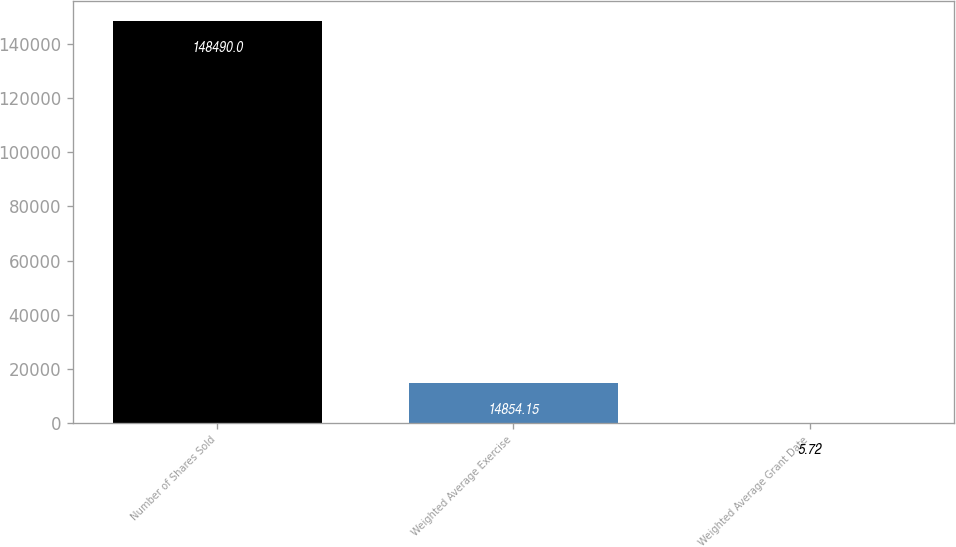Convert chart to OTSL. <chart><loc_0><loc_0><loc_500><loc_500><bar_chart><fcel>Number of Shares Sold<fcel>Weighted Average Exercise<fcel>Weighted Average Grant Date<nl><fcel>148490<fcel>14854.1<fcel>5.72<nl></chart> 